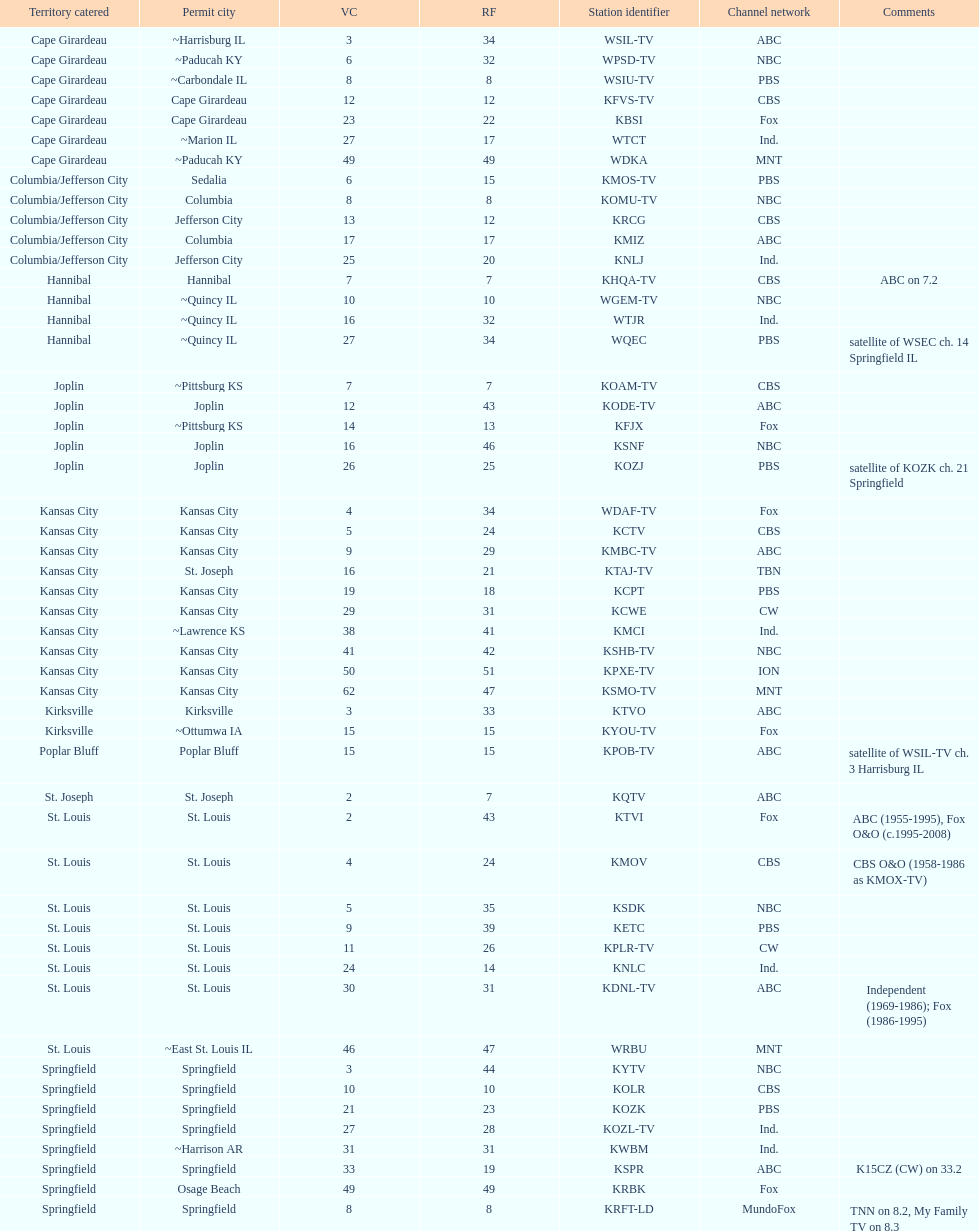Can you parse all the data within this table? {'header': ['Territory catered', 'Permit city', 'VC', 'RF', 'Station identifier', 'Channel network', 'Comments'], 'rows': [['Cape Girardeau', '~Harrisburg IL', '3', '34', 'WSIL-TV', 'ABC', ''], ['Cape Girardeau', '~Paducah KY', '6', '32', 'WPSD-TV', 'NBC', ''], ['Cape Girardeau', '~Carbondale IL', '8', '8', 'WSIU-TV', 'PBS', ''], ['Cape Girardeau', 'Cape Girardeau', '12', '12', 'KFVS-TV', 'CBS', ''], ['Cape Girardeau', 'Cape Girardeau', '23', '22', 'KBSI', 'Fox', ''], ['Cape Girardeau', '~Marion IL', '27', '17', 'WTCT', 'Ind.', ''], ['Cape Girardeau', '~Paducah KY', '49', '49', 'WDKA', 'MNT', ''], ['Columbia/Jefferson City', 'Sedalia', '6', '15', 'KMOS-TV', 'PBS', ''], ['Columbia/Jefferson City', 'Columbia', '8', '8', 'KOMU-TV', 'NBC', ''], ['Columbia/Jefferson City', 'Jefferson City', '13', '12', 'KRCG', 'CBS', ''], ['Columbia/Jefferson City', 'Columbia', '17', '17', 'KMIZ', 'ABC', ''], ['Columbia/Jefferson City', 'Jefferson City', '25', '20', 'KNLJ', 'Ind.', ''], ['Hannibal', 'Hannibal', '7', '7', 'KHQA-TV', 'CBS', 'ABC on 7.2'], ['Hannibal', '~Quincy IL', '10', '10', 'WGEM-TV', 'NBC', ''], ['Hannibal', '~Quincy IL', '16', '32', 'WTJR', 'Ind.', ''], ['Hannibal', '~Quincy IL', '27', '34', 'WQEC', 'PBS', 'satellite of WSEC ch. 14 Springfield IL'], ['Joplin', '~Pittsburg KS', '7', '7', 'KOAM-TV', 'CBS', ''], ['Joplin', 'Joplin', '12', '43', 'KODE-TV', 'ABC', ''], ['Joplin', '~Pittsburg KS', '14', '13', 'KFJX', 'Fox', ''], ['Joplin', 'Joplin', '16', '46', 'KSNF', 'NBC', ''], ['Joplin', 'Joplin', '26', '25', 'KOZJ', 'PBS', 'satellite of KOZK ch. 21 Springfield'], ['Kansas City', 'Kansas City', '4', '34', 'WDAF-TV', 'Fox', ''], ['Kansas City', 'Kansas City', '5', '24', 'KCTV', 'CBS', ''], ['Kansas City', 'Kansas City', '9', '29', 'KMBC-TV', 'ABC', ''], ['Kansas City', 'St. Joseph', '16', '21', 'KTAJ-TV', 'TBN', ''], ['Kansas City', 'Kansas City', '19', '18', 'KCPT', 'PBS', ''], ['Kansas City', 'Kansas City', '29', '31', 'KCWE', 'CW', ''], ['Kansas City', '~Lawrence KS', '38', '41', 'KMCI', 'Ind.', ''], ['Kansas City', 'Kansas City', '41', '42', 'KSHB-TV', 'NBC', ''], ['Kansas City', 'Kansas City', '50', '51', 'KPXE-TV', 'ION', ''], ['Kansas City', 'Kansas City', '62', '47', 'KSMO-TV', 'MNT', ''], ['Kirksville', 'Kirksville', '3', '33', 'KTVO', 'ABC', ''], ['Kirksville', '~Ottumwa IA', '15', '15', 'KYOU-TV', 'Fox', ''], ['Poplar Bluff', 'Poplar Bluff', '15', '15', 'KPOB-TV', 'ABC', 'satellite of WSIL-TV ch. 3 Harrisburg IL'], ['St. Joseph', 'St. Joseph', '2', '7', 'KQTV', 'ABC', ''], ['St. Louis', 'St. Louis', '2', '43', 'KTVI', 'Fox', 'ABC (1955-1995), Fox O&O (c.1995-2008)'], ['St. Louis', 'St. Louis', '4', '24', 'KMOV', 'CBS', 'CBS O&O (1958-1986 as KMOX-TV)'], ['St. Louis', 'St. Louis', '5', '35', 'KSDK', 'NBC', ''], ['St. Louis', 'St. Louis', '9', '39', 'KETC', 'PBS', ''], ['St. Louis', 'St. Louis', '11', '26', 'KPLR-TV', 'CW', ''], ['St. Louis', 'St. Louis', '24', '14', 'KNLC', 'Ind.', ''], ['St. Louis', 'St. Louis', '30', '31', 'KDNL-TV', 'ABC', 'Independent (1969-1986); Fox (1986-1995)'], ['St. Louis', '~East St. Louis IL', '46', '47', 'WRBU', 'MNT', ''], ['Springfield', 'Springfield', '3', '44', 'KYTV', 'NBC', ''], ['Springfield', 'Springfield', '10', '10', 'KOLR', 'CBS', ''], ['Springfield', 'Springfield', '21', '23', 'KOZK', 'PBS', ''], ['Springfield', 'Springfield', '27', '28', 'KOZL-TV', 'Ind.', ''], ['Springfield', '~Harrison AR', '31', '31', 'KWBM', 'Ind.', ''], ['Springfield', 'Springfield', '33', '19', 'KSPR', 'ABC', 'K15CZ (CW) on 33.2'], ['Springfield', 'Osage Beach', '49', '49', 'KRBK', 'Fox', ''], ['Springfield', 'Springfield', '8', '8', 'KRFT-LD', 'MundoFox', 'TNN on 8.2, My Family TV on 8.3']]} Kode-tv and wsil-tv both are a part of which network? ABC. 